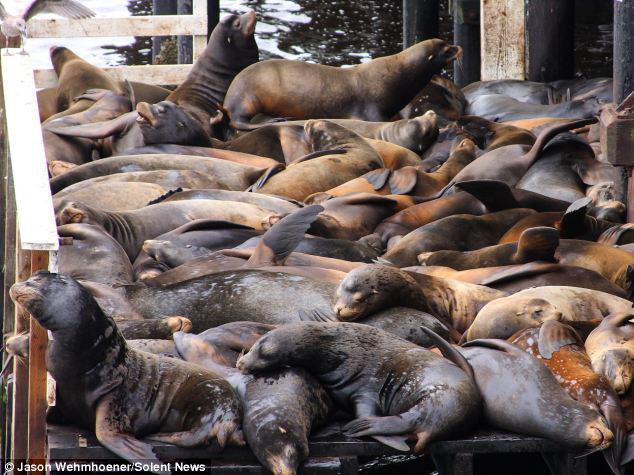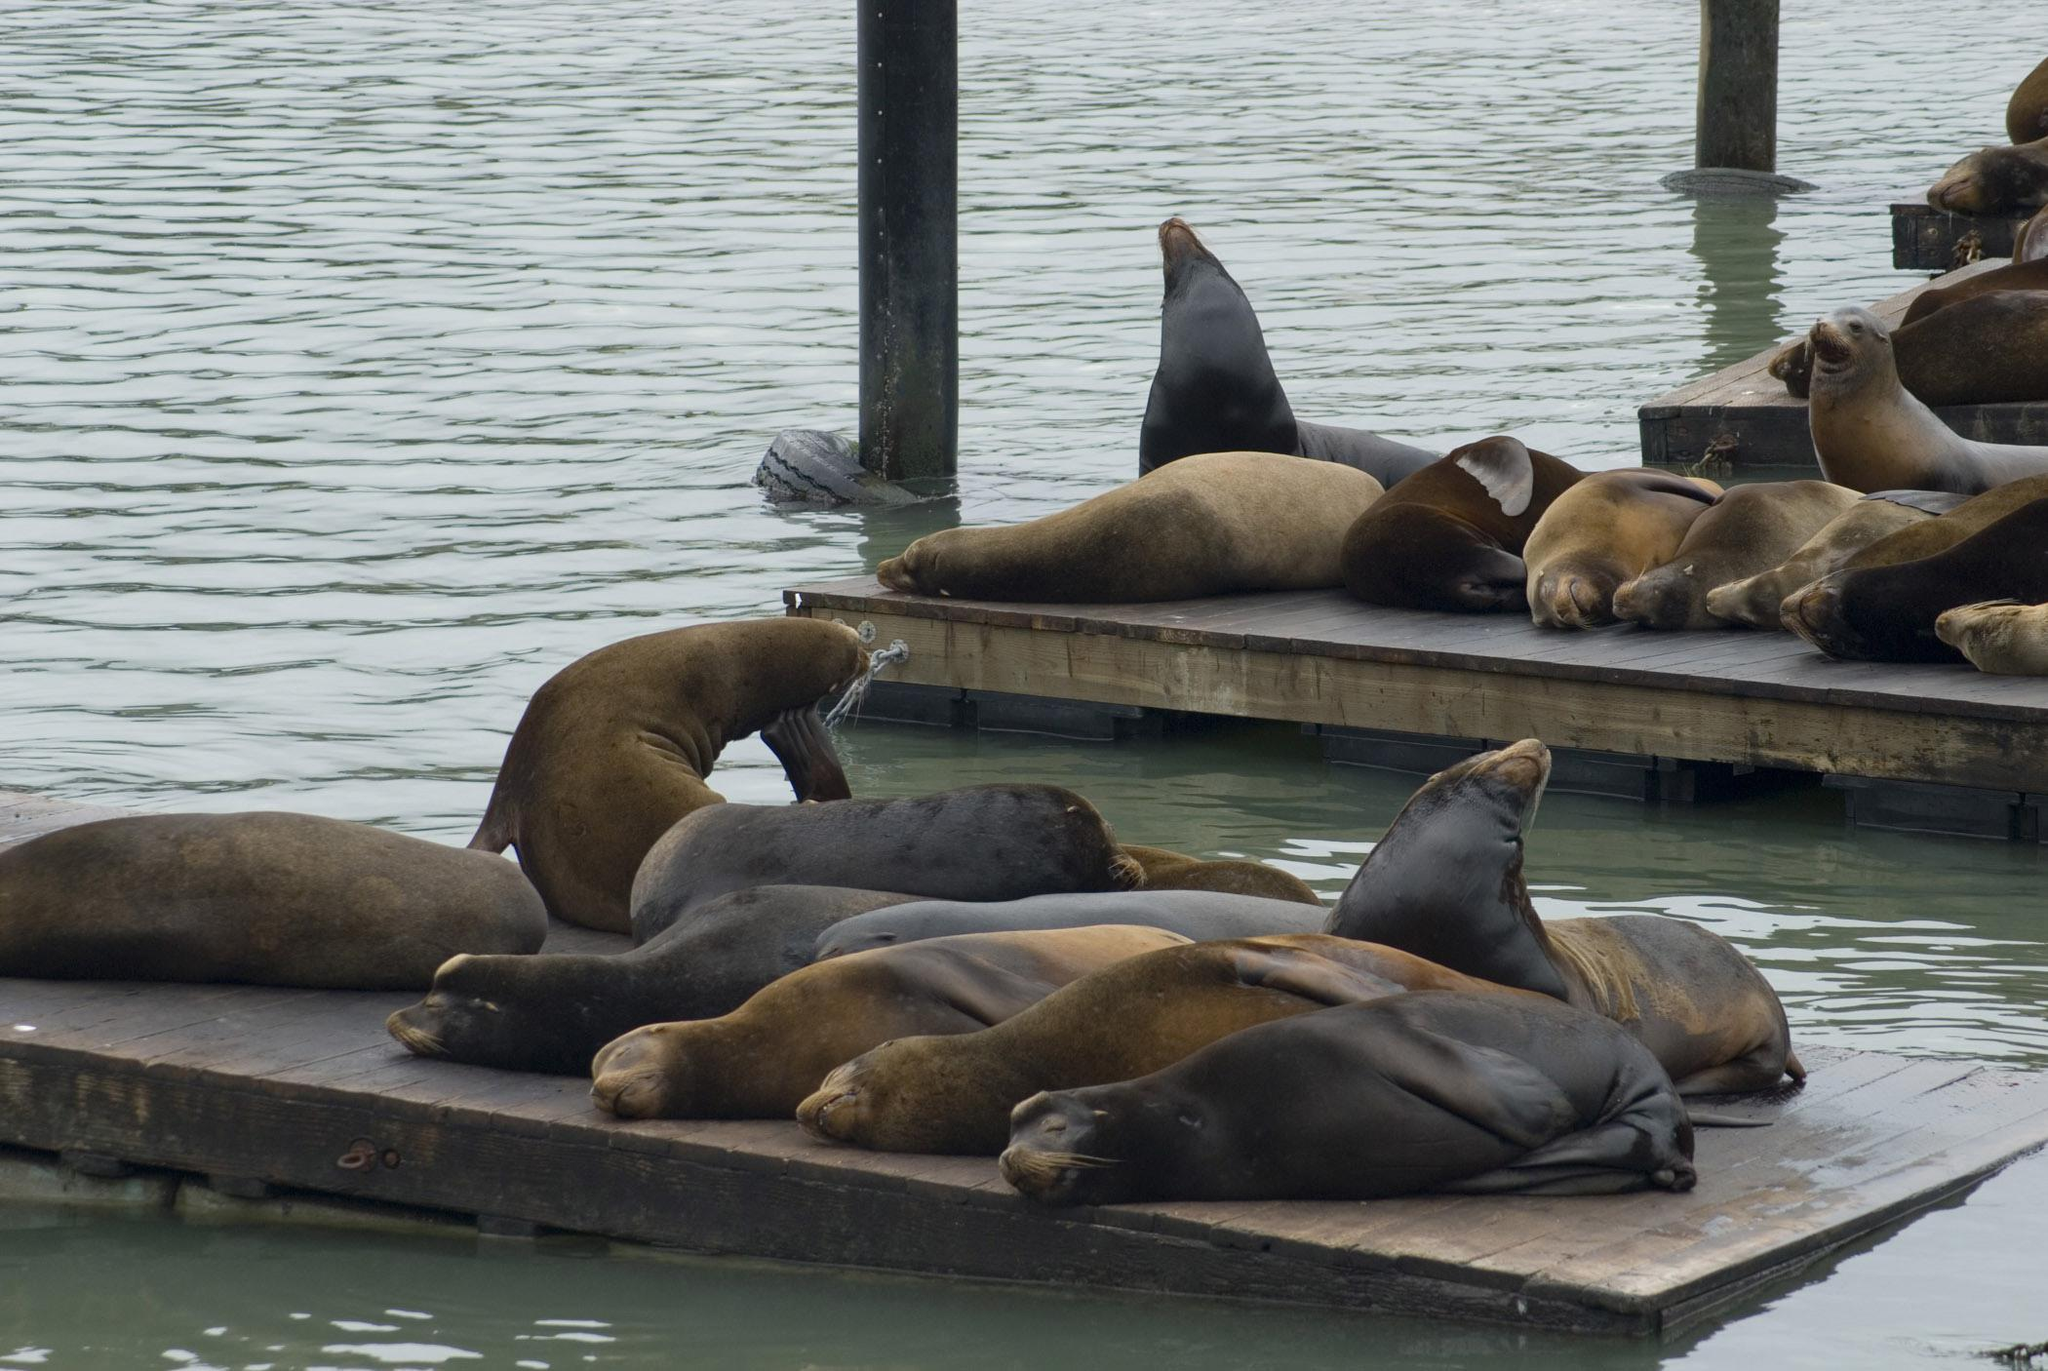The first image is the image on the left, the second image is the image on the right. Evaluate the accuracy of this statement regarding the images: "There are at most two sea lions swimming in water.". Is it true? Answer yes or no. No. The first image is the image on the left, the second image is the image on the right. Given the left and right images, does the statement "A seal's head shows above the water in front of a floating platform packed with seals, in the left image." hold true? Answer yes or no. No. 